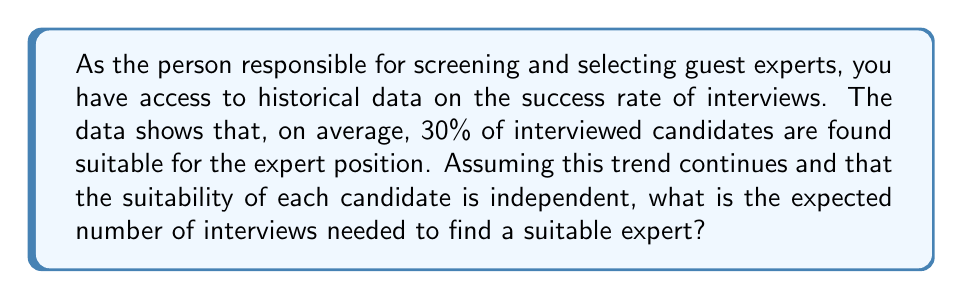What is the answer to this math problem? To solve this problem, we need to use the concept of geometric distribution, which models the number of trials needed to achieve the first success in a series of independent Bernoulli trials.

Let's break down the solution step by step:

1) Let $X$ be the random variable representing the number of interviews needed to find a suitable expert.

2) The probability of success (finding a suitable expert) in each interview is $p = 0.30$ or $30\%$.

3) The probability of failure (not finding a suitable expert) in each interview is $q = 1 - p = 0.70$ or $70\%$.

4) The probability mass function of the geometric distribution is:

   $P(X = k) = q^{k-1}p$, where $k$ is the number of trials until the first success.

5) The expected value (mean) of a geometric distribution is given by:

   $E(X) = \frac{1}{p}$

6) Substituting our value of $p$:

   $E(X) = \frac{1}{0.30} = \frac{10}{3} \approx 3.33$

Therefore, the expected number of interviews needed to find a suitable expert is $\frac{10}{3}$ or approximately 3.33 interviews.
Answer: $E(X) = \frac{10}{3} \approx 3.33$ interviews 